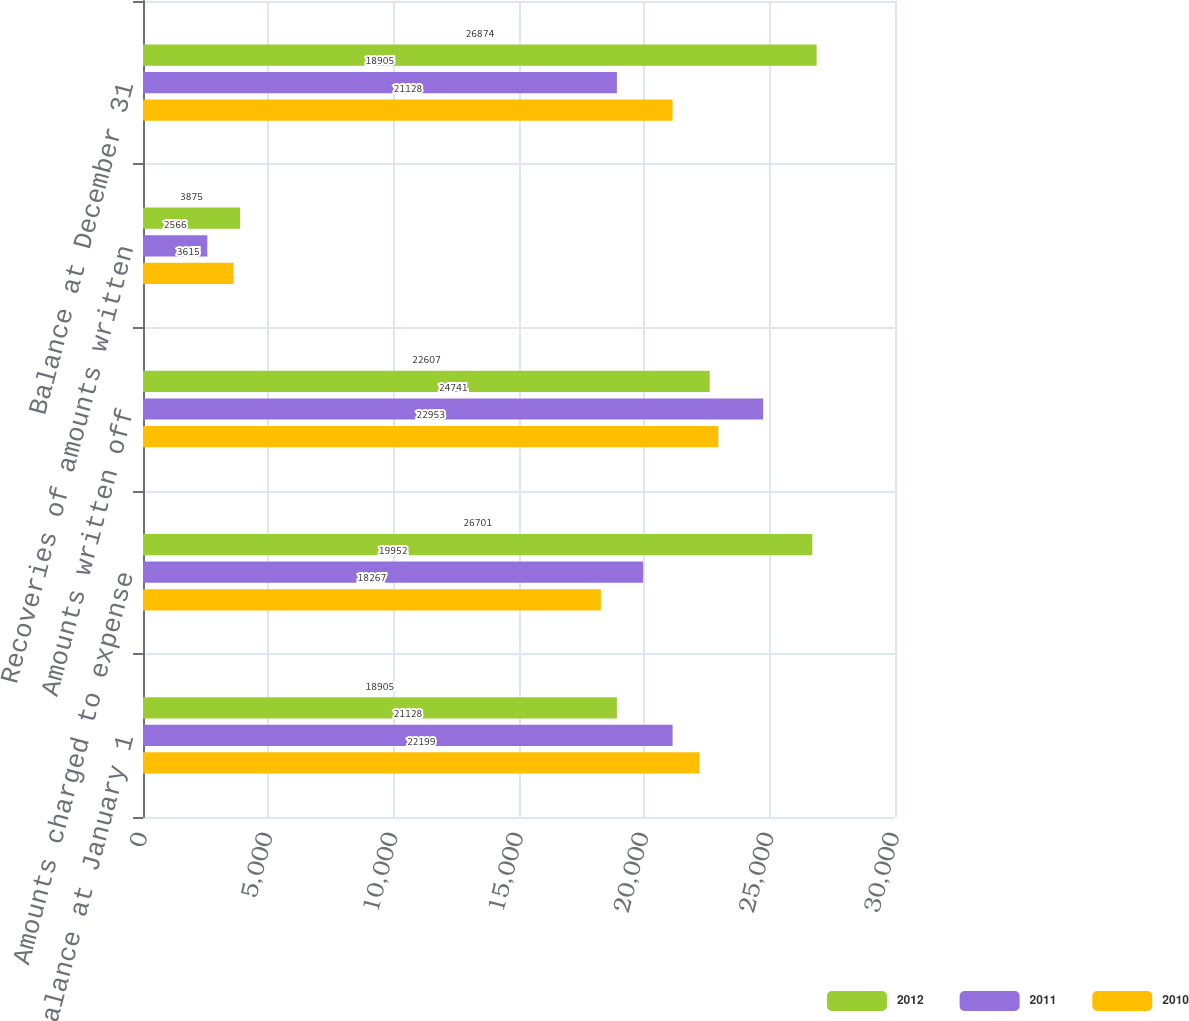Convert chart to OTSL. <chart><loc_0><loc_0><loc_500><loc_500><stacked_bar_chart><ecel><fcel>Balance at January 1<fcel>Amounts charged to expense<fcel>Amounts written off<fcel>Recoveries of amounts written<fcel>Balance at December 31<nl><fcel>2012<fcel>18905<fcel>26701<fcel>22607<fcel>3875<fcel>26874<nl><fcel>2011<fcel>21128<fcel>19952<fcel>24741<fcel>2566<fcel>18905<nl><fcel>2010<fcel>22199<fcel>18267<fcel>22953<fcel>3615<fcel>21128<nl></chart> 